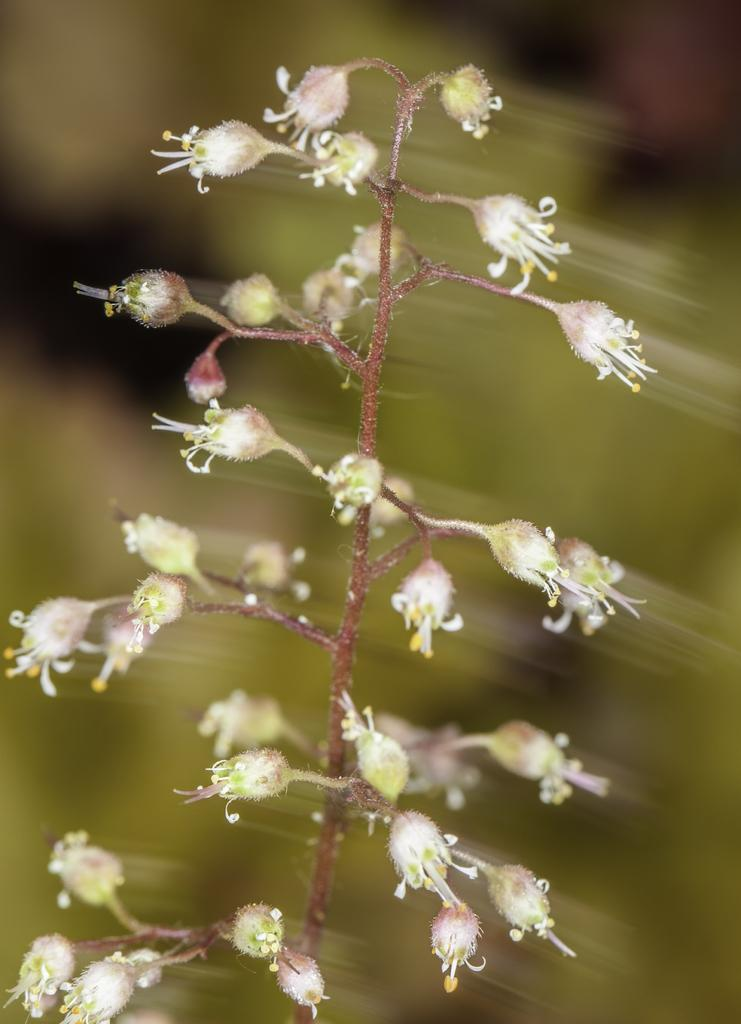What is the main subject of the image? The main subject of the image is a flowering plant. Can you describe the plant's current stage of growth? There are buds on the plant, indicating that it is in the process of blooming. What is the purpose of the structure visible in the image? There is no structure visible in the image; it only features a flowering plant with buds. 